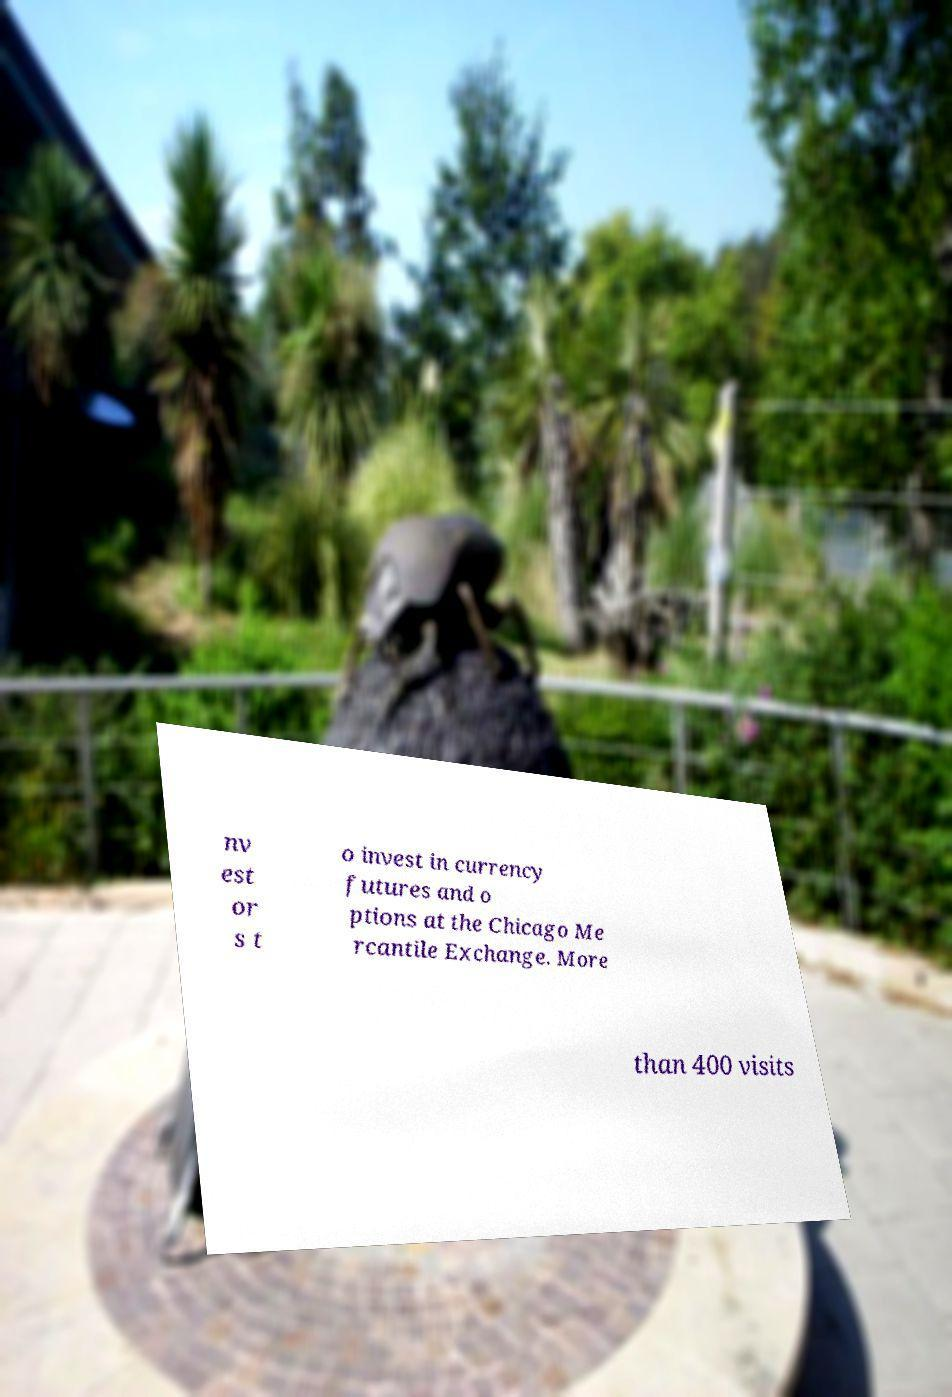Could you extract and type out the text from this image? nv est or s t o invest in currency futures and o ptions at the Chicago Me rcantile Exchange. More than 400 visits 